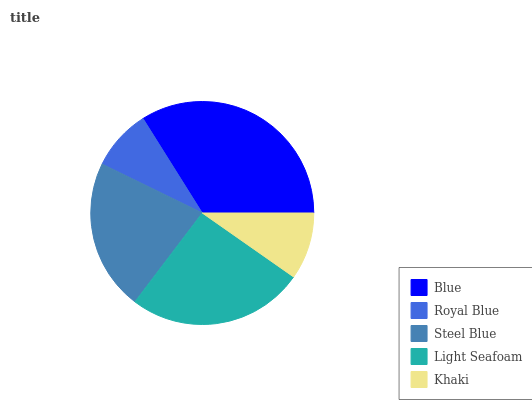Is Royal Blue the minimum?
Answer yes or no. Yes. Is Blue the maximum?
Answer yes or no. Yes. Is Steel Blue the minimum?
Answer yes or no. No. Is Steel Blue the maximum?
Answer yes or no. No. Is Steel Blue greater than Royal Blue?
Answer yes or no. Yes. Is Royal Blue less than Steel Blue?
Answer yes or no. Yes. Is Royal Blue greater than Steel Blue?
Answer yes or no. No. Is Steel Blue less than Royal Blue?
Answer yes or no. No. Is Steel Blue the high median?
Answer yes or no. Yes. Is Steel Blue the low median?
Answer yes or no. Yes. Is Khaki the high median?
Answer yes or no. No. Is Royal Blue the low median?
Answer yes or no. No. 